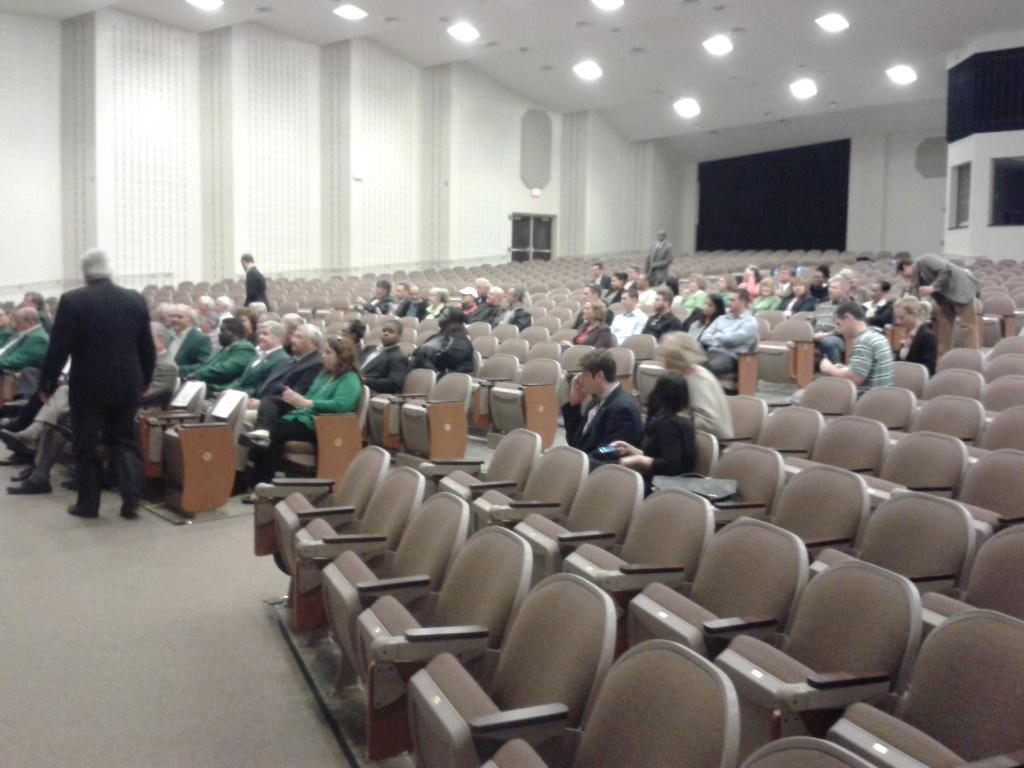What is the main subject of the image? The main subject of the image is a group of people. What are the people in the image doing? Some of the people are seated on chairs, while others are standing. Can you describe any additional features in the image? There are lights on the roof. What type of attack is being carried out by the people in the image? There is no attack being carried out by the people in the image; they are simply standing or seated. Can you tell me how many lamps are present in the image? There is no lamp present in the image; only lights on the roof are visible. 